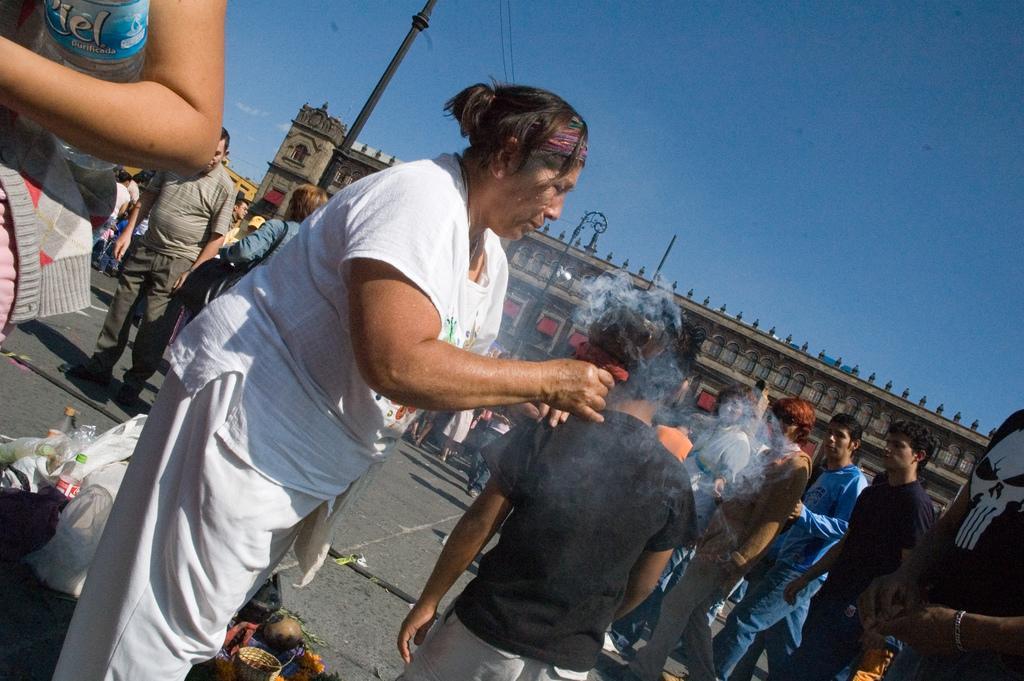Could you give a brief overview of what you see in this image? This picture consists of building, in front of building poles and persons visible , in the foreground I can see a woman holding an object and I can see there are bottles and covers kept on road on the left side, at the top I can see the sky. 